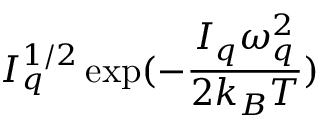Convert formula to latex. <formula><loc_0><loc_0><loc_500><loc_500>I _ { q } ^ { 1 / 2 } \exp ( - \frac { I _ { q } \omega _ { q } ^ { 2 } } { 2 k _ { B } T } )</formula> 